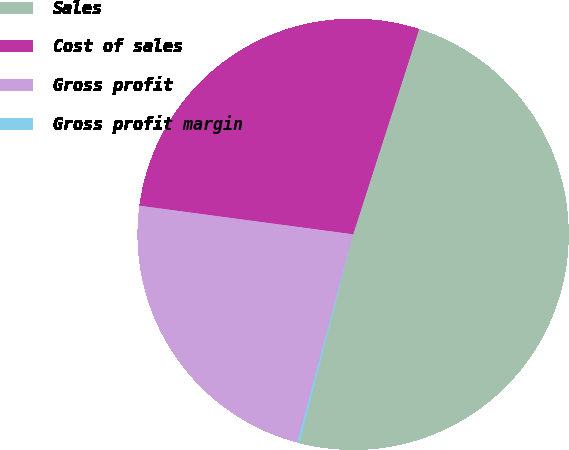Convert chart. <chart><loc_0><loc_0><loc_500><loc_500><pie_chart><fcel>Sales<fcel>Cost of sales<fcel>Gross profit<fcel>Gross profit margin<nl><fcel>49.04%<fcel>27.83%<fcel>22.94%<fcel>0.18%<nl></chart> 